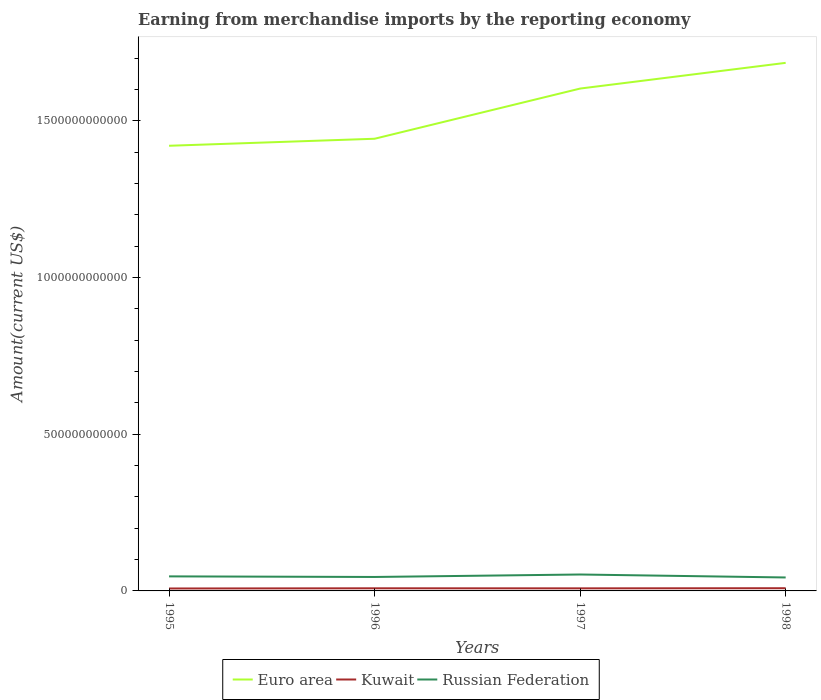Does the line corresponding to Russian Federation intersect with the line corresponding to Kuwait?
Provide a short and direct response. No. Across all years, what is the maximum amount earned from merchandise imports in Euro area?
Keep it short and to the point. 1.42e+12. What is the total amount earned from merchandise imports in Russian Federation in the graph?
Make the answer very short. 9.46e+09. What is the difference between the highest and the second highest amount earned from merchandise imports in Euro area?
Provide a short and direct response. 2.65e+11. Is the amount earned from merchandise imports in Russian Federation strictly greater than the amount earned from merchandise imports in Euro area over the years?
Provide a short and direct response. Yes. How many years are there in the graph?
Your answer should be very brief. 4. What is the difference between two consecutive major ticks on the Y-axis?
Your response must be concise. 5.00e+11. Are the values on the major ticks of Y-axis written in scientific E-notation?
Make the answer very short. No. Does the graph contain any zero values?
Provide a succinct answer. No. Where does the legend appear in the graph?
Keep it short and to the point. Bottom center. How are the legend labels stacked?
Offer a terse response. Horizontal. What is the title of the graph?
Make the answer very short. Earning from merchandise imports by the reporting economy. What is the label or title of the Y-axis?
Provide a succinct answer. Amount(current US$). What is the Amount(current US$) in Euro area in 1995?
Provide a succinct answer. 1.42e+12. What is the Amount(current US$) in Kuwait in 1995?
Offer a very short reply. 7.77e+09. What is the Amount(current US$) in Russian Federation in 1995?
Ensure brevity in your answer.  4.64e+1. What is the Amount(current US$) in Euro area in 1996?
Give a very brief answer. 1.44e+12. What is the Amount(current US$) of Kuwait in 1996?
Offer a very short reply. 8.37e+09. What is the Amount(current US$) of Russian Federation in 1996?
Offer a very short reply. 4.45e+1. What is the Amount(current US$) in Euro area in 1997?
Keep it short and to the point. 1.60e+12. What is the Amount(current US$) of Kuwait in 1997?
Your answer should be very brief. 8.21e+09. What is the Amount(current US$) in Russian Federation in 1997?
Provide a succinct answer. 5.24e+1. What is the Amount(current US$) of Euro area in 1998?
Ensure brevity in your answer.  1.68e+12. What is the Amount(current US$) in Kuwait in 1998?
Keep it short and to the point. 8.62e+09. What is the Amount(current US$) in Russian Federation in 1998?
Ensure brevity in your answer.  4.29e+1. Across all years, what is the maximum Amount(current US$) in Euro area?
Your answer should be compact. 1.68e+12. Across all years, what is the maximum Amount(current US$) in Kuwait?
Give a very brief answer. 8.62e+09. Across all years, what is the maximum Amount(current US$) of Russian Federation?
Make the answer very short. 5.24e+1. Across all years, what is the minimum Amount(current US$) of Euro area?
Offer a very short reply. 1.42e+12. Across all years, what is the minimum Amount(current US$) of Kuwait?
Make the answer very short. 7.77e+09. Across all years, what is the minimum Amount(current US$) in Russian Federation?
Offer a terse response. 4.29e+1. What is the total Amount(current US$) of Euro area in the graph?
Give a very brief answer. 6.15e+12. What is the total Amount(current US$) of Kuwait in the graph?
Offer a very short reply. 3.30e+1. What is the total Amount(current US$) in Russian Federation in the graph?
Give a very brief answer. 1.86e+11. What is the difference between the Amount(current US$) in Euro area in 1995 and that in 1996?
Offer a terse response. -2.24e+1. What is the difference between the Amount(current US$) of Kuwait in 1995 and that in 1996?
Your answer should be compact. -6.02e+08. What is the difference between the Amount(current US$) of Russian Federation in 1995 and that in 1996?
Your answer should be very brief. 1.90e+09. What is the difference between the Amount(current US$) of Euro area in 1995 and that in 1997?
Keep it short and to the point. -1.83e+11. What is the difference between the Amount(current US$) in Kuwait in 1995 and that in 1997?
Your answer should be compact. -4.43e+08. What is the difference between the Amount(current US$) of Russian Federation in 1995 and that in 1997?
Your response must be concise. -6.00e+09. What is the difference between the Amount(current US$) in Euro area in 1995 and that in 1998?
Give a very brief answer. -2.65e+11. What is the difference between the Amount(current US$) of Kuwait in 1995 and that in 1998?
Provide a succinct answer. -8.46e+08. What is the difference between the Amount(current US$) in Russian Federation in 1995 and that in 1998?
Provide a short and direct response. 3.46e+09. What is the difference between the Amount(current US$) of Euro area in 1996 and that in 1997?
Your response must be concise. -1.60e+11. What is the difference between the Amount(current US$) of Kuwait in 1996 and that in 1997?
Give a very brief answer. 1.59e+08. What is the difference between the Amount(current US$) of Russian Federation in 1996 and that in 1997?
Provide a short and direct response. -7.90e+09. What is the difference between the Amount(current US$) in Euro area in 1996 and that in 1998?
Provide a short and direct response. -2.42e+11. What is the difference between the Amount(current US$) in Kuwait in 1996 and that in 1998?
Give a very brief answer. -2.43e+08. What is the difference between the Amount(current US$) in Russian Federation in 1996 and that in 1998?
Your answer should be compact. 1.57e+09. What is the difference between the Amount(current US$) of Euro area in 1997 and that in 1998?
Make the answer very short. -8.20e+1. What is the difference between the Amount(current US$) in Kuwait in 1997 and that in 1998?
Keep it short and to the point. -4.03e+08. What is the difference between the Amount(current US$) in Russian Federation in 1997 and that in 1998?
Ensure brevity in your answer.  9.46e+09. What is the difference between the Amount(current US$) of Euro area in 1995 and the Amount(current US$) of Kuwait in 1996?
Offer a very short reply. 1.41e+12. What is the difference between the Amount(current US$) of Euro area in 1995 and the Amount(current US$) of Russian Federation in 1996?
Your response must be concise. 1.38e+12. What is the difference between the Amount(current US$) of Kuwait in 1995 and the Amount(current US$) of Russian Federation in 1996?
Ensure brevity in your answer.  -3.67e+1. What is the difference between the Amount(current US$) in Euro area in 1995 and the Amount(current US$) in Kuwait in 1997?
Your answer should be compact. 1.41e+12. What is the difference between the Amount(current US$) in Euro area in 1995 and the Amount(current US$) in Russian Federation in 1997?
Give a very brief answer. 1.37e+12. What is the difference between the Amount(current US$) in Kuwait in 1995 and the Amount(current US$) in Russian Federation in 1997?
Give a very brief answer. -4.46e+1. What is the difference between the Amount(current US$) of Euro area in 1995 and the Amount(current US$) of Kuwait in 1998?
Provide a succinct answer. 1.41e+12. What is the difference between the Amount(current US$) of Euro area in 1995 and the Amount(current US$) of Russian Federation in 1998?
Make the answer very short. 1.38e+12. What is the difference between the Amount(current US$) of Kuwait in 1995 and the Amount(current US$) of Russian Federation in 1998?
Provide a succinct answer. -3.52e+1. What is the difference between the Amount(current US$) in Euro area in 1996 and the Amount(current US$) in Kuwait in 1997?
Provide a succinct answer. 1.43e+12. What is the difference between the Amount(current US$) in Euro area in 1996 and the Amount(current US$) in Russian Federation in 1997?
Offer a very short reply. 1.39e+12. What is the difference between the Amount(current US$) of Kuwait in 1996 and the Amount(current US$) of Russian Federation in 1997?
Give a very brief answer. -4.40e+1. What is the difference between the Amount(current US$) in Euro area in 1996 and the Amount(current US$) in Kuwait in 1998?
Give a very brief answer. 1.43e+12. What is the difference between the Amount(current US$) in Euro area in 1996 and the Amount(current US$) in Russian Federation in 1998?
Your answer should be very brief. 1.40e+12. What is the difference between the Amount(current US$) of Kuwait in 1996 and the Amount(current US$) of Russian Federation in 1998?
Make the answer very short. -3.46e+1. What is the difference between the Amount(current US$) in Euro area in 1997 and the Amount(current US$) in Kuwait in 1998?
Your answer should be compact. 1.59e+12. What is the difference between the Amount(current US$) in Euro area in 1997 and the Amount(current US$) in Russian Federation in 1998?
Give a very brief answer. 1.56e+12. What is the difference between the Amount(current US$) of Kuwait in 1997 and the Amount(current US$) of Russian Federation in 1998?
Your answer should be very brief. -3.47e+1. What is the average Amount(current US$) of Euro area per year?
Provide a short and direct response. 1.54e+12. What is the average Amount(current US$) of Kuwait per year?
Offer a very short reply. 8.24e+09. What is the average Amount(current US$) in Russian Federation per year?
Your answer should be very brief. 4.66e+1. In the year 1995, what is the difference between the Amount(current US$) in Euro area and Amount(current US$) in Kuwait?
Ensure brevity in your answer.  1.41e+12. In the year 1995, what is the difference between the Amount(current US$) in Euro area and Amount(current US$) in Russian Federation?
Provide a short and direct response. 1.37e+12. In the year 1995, what is the difference between the Amount(current US$) of Kuwait and Amount(current US$) of Russian Federation?
Offer a very short reply. -3.86e+1. In the year 1996, what is the difference between the Amount(current US$) in Euro area and Amount(current US$) in Kuwait?
Provide a short and direct response. 1.43e+12. In the year 1996, what is the difference between the Amount(current US$) in Euro area and Amount(current US$) in Russian Federation?
Offer a terse response. 1.40e+12. In the year 1996, what is the difference between the Amount(current US$) of Kuwait and Amount(current US$) of Russian Federation?
Your response must be concise. -3.61e+1. In the year 1997, what is the difference between the Amount(current US$) of Euro area and Amount(current US$) of Kuwait?
Your answer should be compact. 1.59e+12. In the year 1997, what is the difference between the Amount(current US$) in Euro area and Amount(current US$) in Russian Federation?
Offer a very short reply. 1.55e+12. In the year 1997, what is the difference between the Amount(current US$) in Kuwait and Amount(current US$) in Russian Federation?
Your response must be concise. -4.42e+1. In the year 1998, what is the difference between the Amount(current US$) in Euro area and Amount(current US$) in Kuwait?
Offer a very short reply. 1.68e+12. In the year 1998, what is the difference between the Amount(current US$) of Euro area and Amount(current US$) of Russian Federation?
Give a very brief answer. 1.64e+12. In the year 1998, what is the difference between the Amount(current US$) in Kuwait and Amount(current US$) in Russian Federation?
Provide a succinct answer. -3.43e+1. What is the ratio of the Amount(current US$) of Euro area in 1995 to that in 1996?
Your response must be concise. 0.98. What is the ratio of the Amount(current US$) in Kuwait in 1995 to that in 1996?
Your response must be concise. 0.93. What is the ratio of the Amount(current US$) of Russian Federation in 1995 to that in 1996?
Offer a terse response. 1.04. What is the ratio of the Amount(current US$) in Euro area in 1995 to that in 1997?
Give a very brief answer. 0.89. What is the ratio of the Amount(current US$) in Kuwait in 1995 to that in 1997?
Offer a very short reply. 0.95. What is the ratio of the Amount(current US$) in Russian Federation in 1995 to that in 1997?
Your answer should be very brief. 0.89. What is the ratio of the Amount(current US$) in Euro area in 1995 to that in 1998?
Give a very brief answer. 0.84. What is the ratio of the Amount(current US$) in Kuwait in 1995 to that in 1998?
Make the answer very short. 0.9. What is the ratio of the Amount(current US$) in Russian Federation in 1995 to that in 1998?
Your response must be concise. 1.08. What is the ratio of the Amount(current US$) in Euro area in 1996 to that in 1997?
Make the answer very short. 0.9. What is the ratio of the Amount(current US$) of Kuwait in 1996 to that in 1997?
Provide a short and direct response. 1.02. What is the ratio of the Amount(current US$) of Russian Federation in 1996 to that in 1997?
Offer a very short reply. 0.85. What is the ratio of the Amount(current US$) of Euro area in 1996 to that in 1998?
Your response must be concise. 0.86. What is the ratio of the Amount(current US$) of Kuwait in 1996 to that in 1998?
Provide a succinct answer. 0.97. What is the ratio of the Amount(current US$) of Russian Federation in 1996 to that in 1998?
Provide a succinct answer. 1.04. What is the ratio of the Amount(current US$) of Euro area in 1997 to that in 1998?
Keep it short and to the point. 0.95. What is the ratio of the Amount(current US$) of Kuwait in 1997 to that in 1998?
Your response must be concise. 0.95. What is the ratio of the Amount(current US$) in Russian Federation in 1997 to that in 1998?
Your response must be concise. 1.22. What is the difference between the highest and the second highest Amount(current US$) of Euro area?
Your answer should be very brief. 8.20e+1. What is the difference between the highest and the second highest Amount(current US$) of Kuwait?
Offer a terse response. 2.43e+08. What is the difference between the highest and the second highest Amount(current US$) in Russian Federation?
Offer a terse response. 6.00e+09. What is the difference between the highest and the lowest Amount(current US$) of Euro area?
Ensure brevity in your answer.  2.65e+11. What is the difference between the highest and the lowest Amount(current US$) of Kuwait?
Ensure brevity in your answer.  8.46e+08. What is the difference between the highest and the lowest Amount(current US$) in Russian Federation?
Your response must be concise. 9.46e+09. 